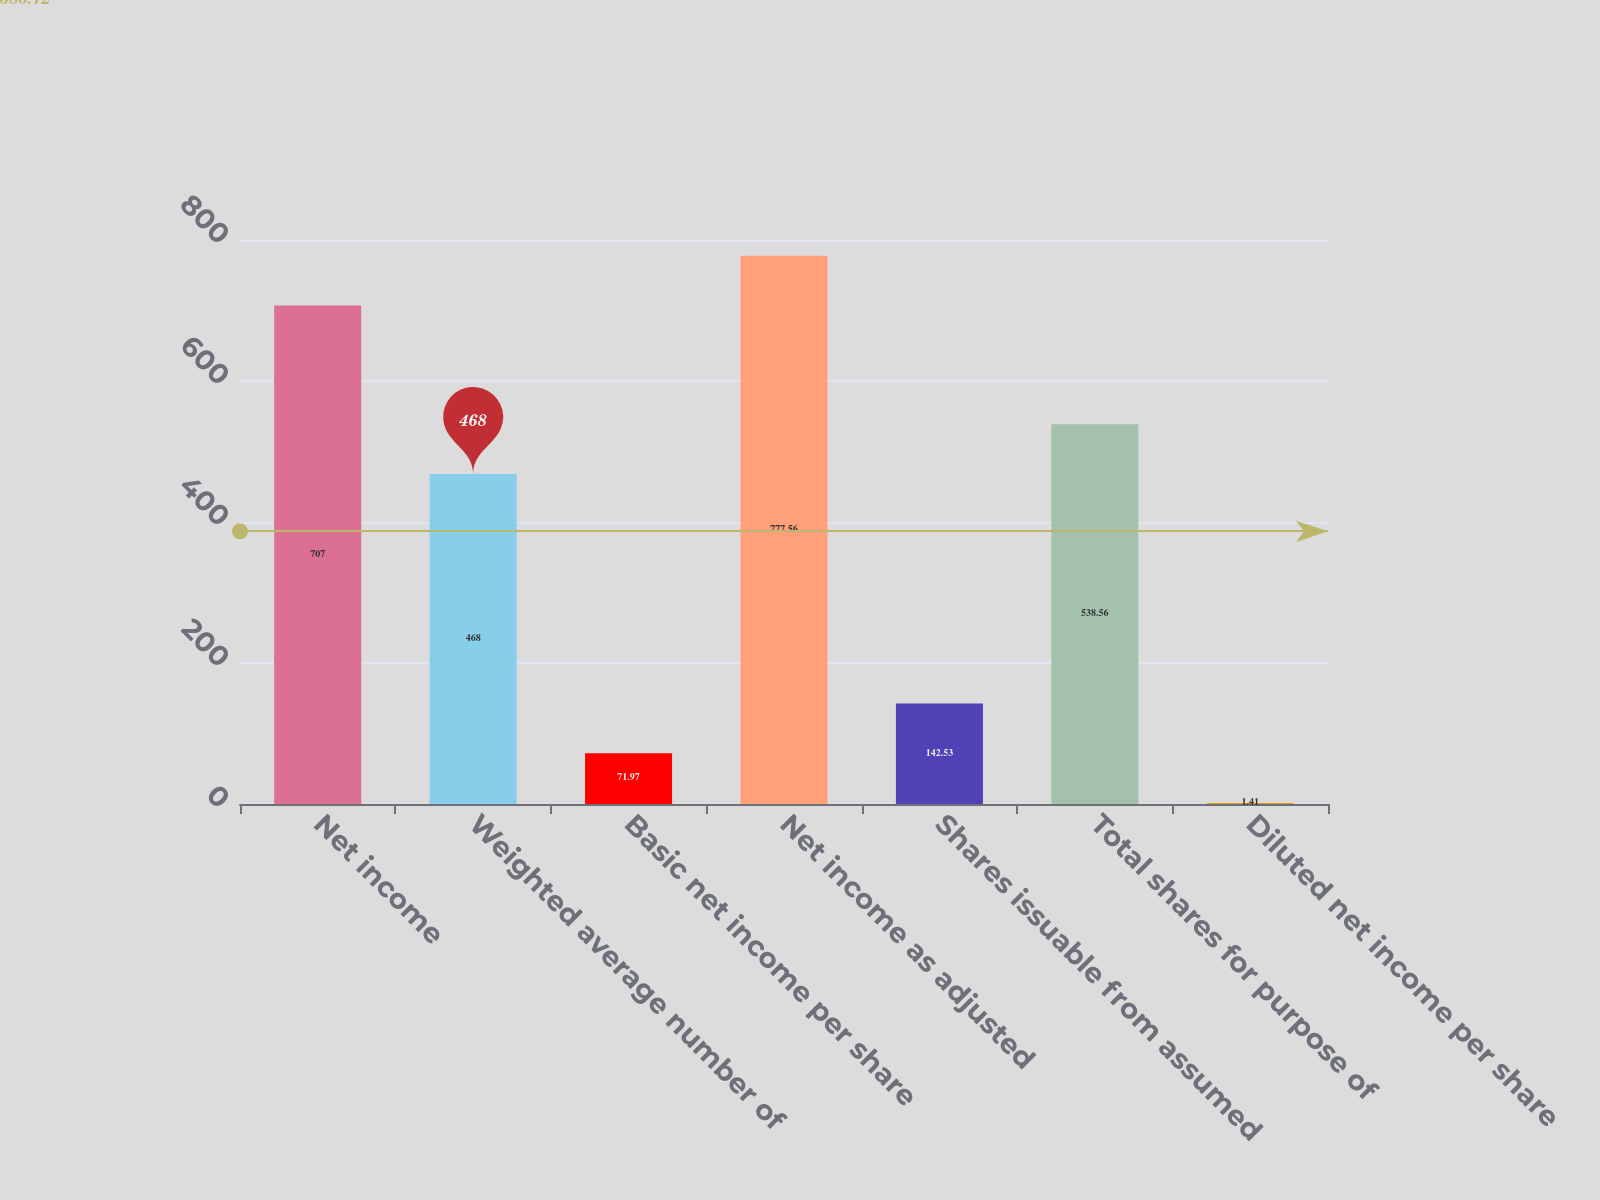Convert chart. <chart><loc_0><loc_0><loc_500><loc_500><bar_chart><fcel>Net income<fcel>Weighted average number of<fcel>Basic net income per share<fcel>Net income as adjusted<fcel>Shares issuable from assumed<fcel>Total shares for purpose of<fcel>Diluted net income per share<nl><fcel>707<fcel>468<fcel>71.97<fcel>777.56<fcel>142.53<fcel>538.56<fcel>1.41<nl></chart> 